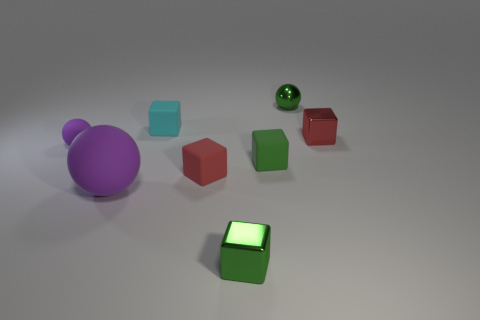Add 1 tiny red shiny balls. How many objects exist? 9 Subtract all cyan blocks. How many blocks are left? 4 Subtract all cyan cubes. How many cubes are left? 4 Subtract all spheres. How many objects are left? 5 Subtract all yellow cylinders. How many brown balls are left? 0 Add 3 green shiny blocks. How many green shiny blocks exist? 4 Subtract 0 gray blocks. How many objects are left? 8 Subtract 3 cubes. How many cubes are left? 2 Subtract all red spheres. Subtract all yellow cylinders. How many spheres are left? 3 Subtract all big rubber things. Subtract all cyan objects. How many objects are left? 6 